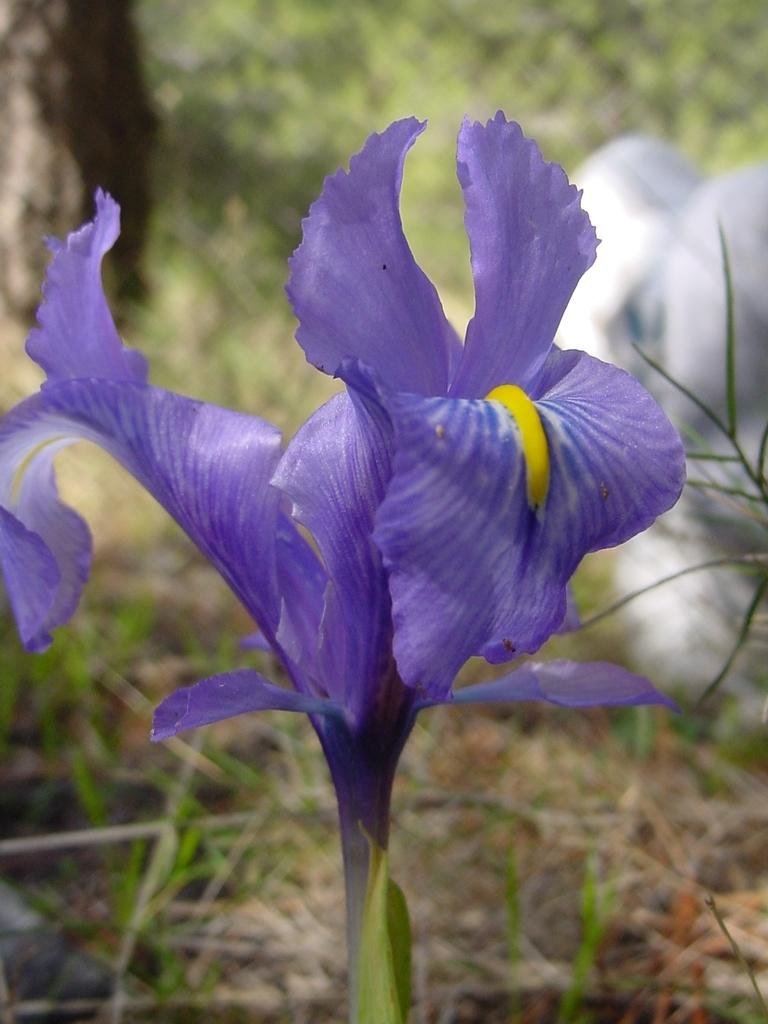What is the main subject in the foreground of the image? There is a flower with a stem in the foreground of the image. What color are the petals of the flower? The petals of the flower are blue. What can be seen in the background of the image? There are many plants in the background of the image. What color is the object on the right side of the image? There is a white color object on the right side of the image. How many beads are scattered around the flower in the image? There are no beads present in the image. What type of egg can be seen in the image? There are no eggs present in the image. 